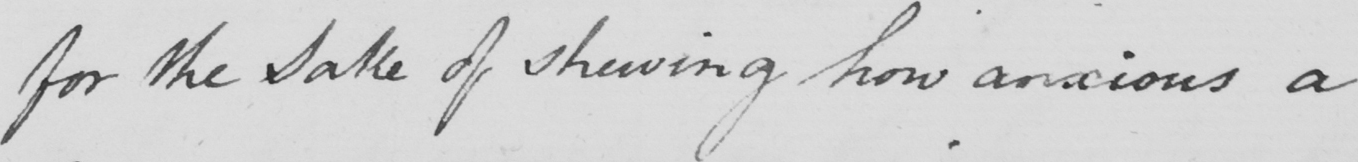Can you read and transcribe this handwriting? for the Sake of shewing how anxious a 